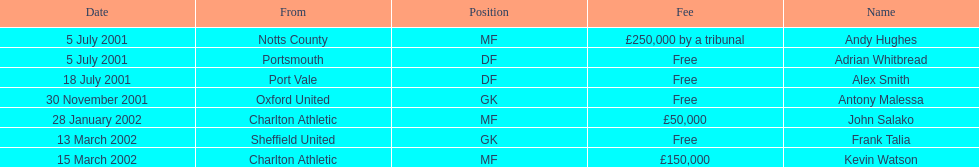What was the transfer fee to transfer kevin watson? £150,000. 